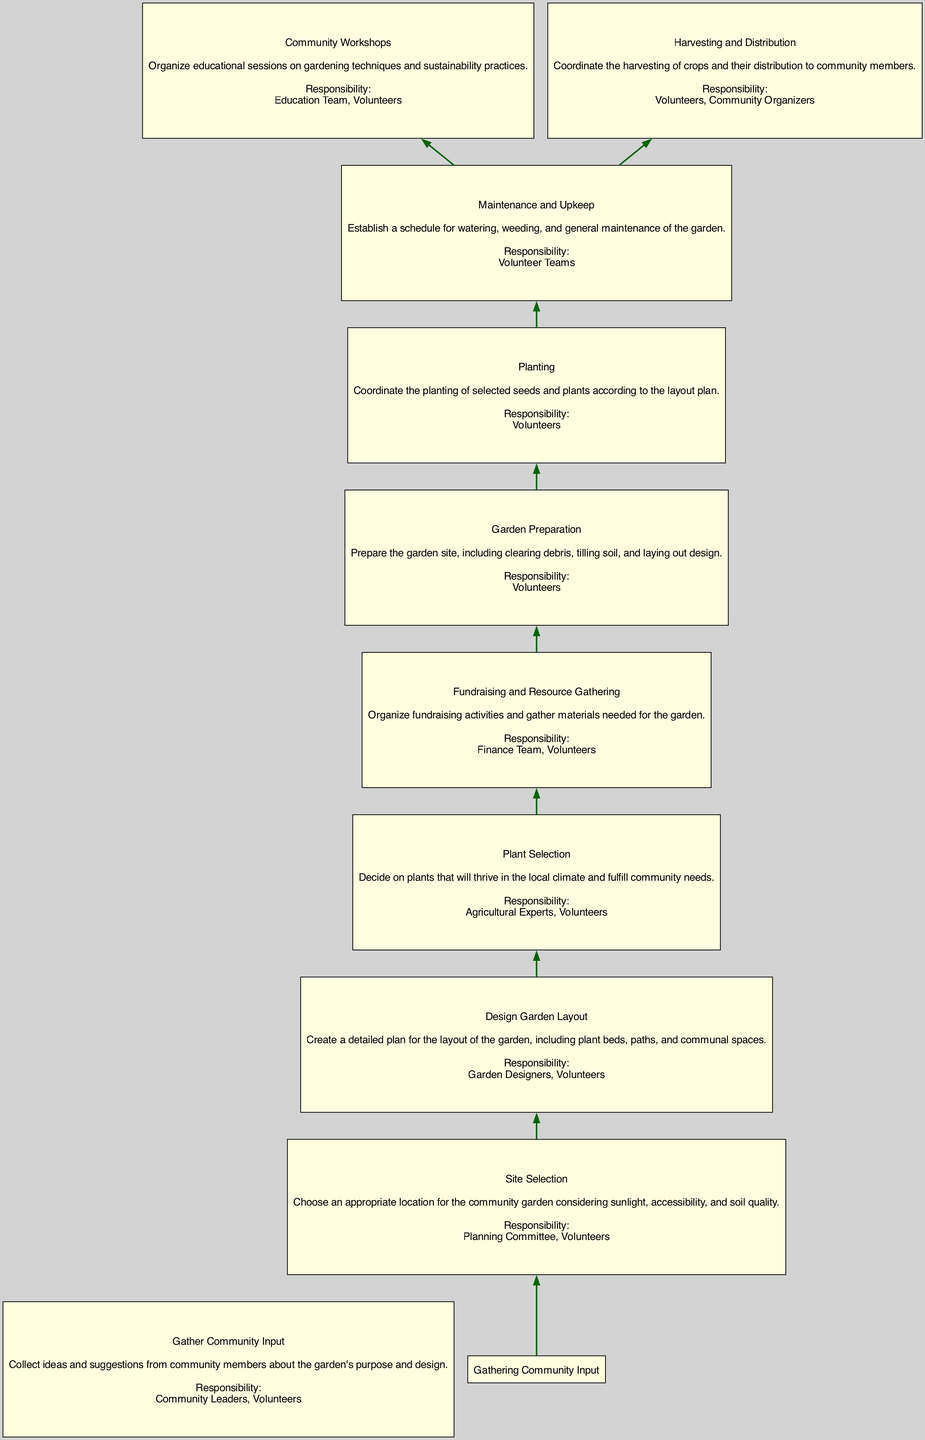What is the first task in the flow chart? The first task in the flow chart is "Gather Community Input". This is located at the bottom of the flow diagram, indicating it is the starting point of the project planning.
Answer: Gather Community Input Who is responsible for the "Plant Selection" task? The "Plant Selection" task lists "Agricultural Experts, Volunteers" as responsible. This information is included in the node describing this task in the diagram.
Answer: Agricultural Experts, Volunteers How many tasks are involved in total? There are 10 tasks listed in the diagram, counting each individual task as a separate entity represented by a node.
Answer: 10 What task follows "Site Selection"? "Design Garden Layout" directly follows "Site Selection" in the flow from one task to another, indicating the sequence of project steps.
Answer: Design Garden Layout Which task is responsible for educational sessions? The task "Community Workshops" is responsible for organizing educational sessions on gardening techniques and sustainability practices. This is specified in the task's description within the flow.
Answer: Community Workshops What is the relationship between "Maintenance and Upkeep" and "Harvesting and Distribution"? "Maintenance and Upkeep" is a precursor task to "Harvesting and Distribution", indicating that the garden maintenance must happen before the harvesting can take place, as illustrated by the connecting edge in the diagram.
Answer: Precursor Which task has only volunteers responsible for it? "Garden Preparation" is the only task where only "Volunteers" are listed as the responsible party, as indicated in its node.
Answer: Garden Preparation How many edges are present in the diagram? The diagram includes 9 edges, which represent the connections between the various tasks in the flow, showing the direction of project progression.
Answer: 9 What is the last task in the flow chart? The last task in the flow chart is "Harvesting and Distribution", indicating it comes at the end of the project planning process, as shown at the end of the flow.
Answer: Harvesting and Distribution 